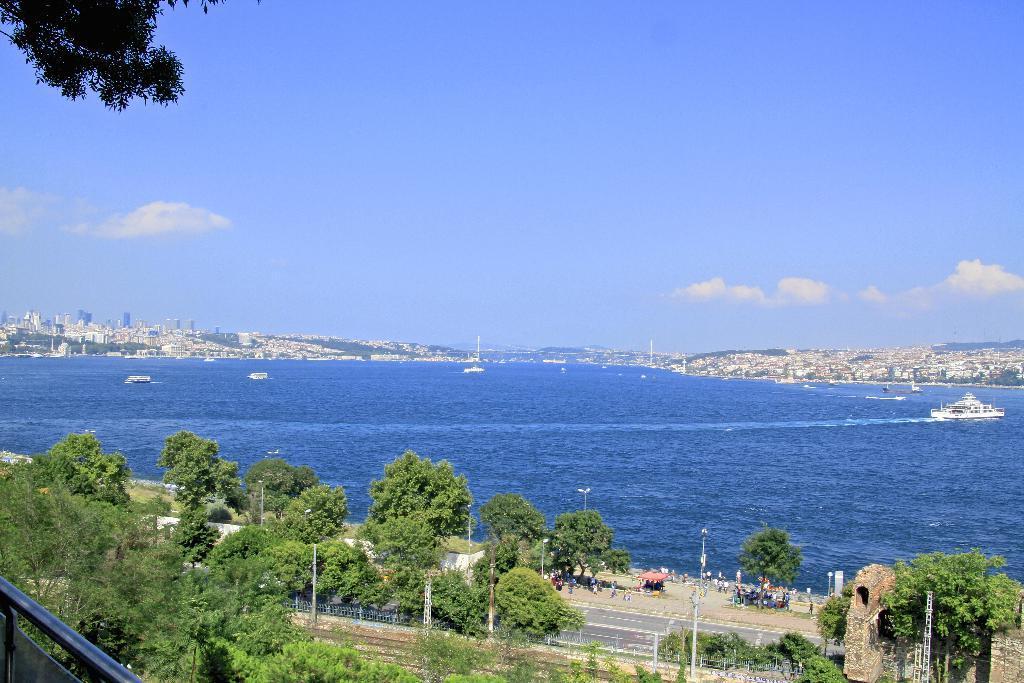Could you give a brief overview of what you see in this image? In this picture we can see water and on water here it is a ship and besides to this water we have some hills, buildings and trees and here it is a road and besides to this there are paths for people to stay one there and watch the scenario and above this we have sky with clouds and on left side we can see some fence with metal. 